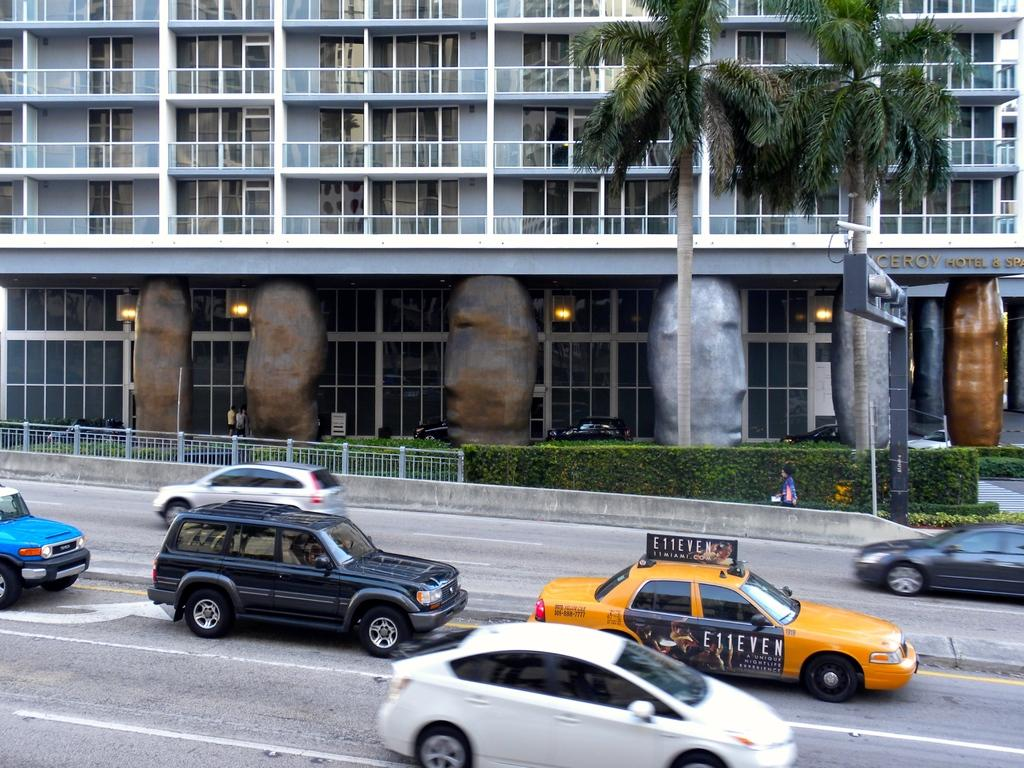<image>
Render a clear and concise summary of the photo. the title Eleven is on the side of the taxi 